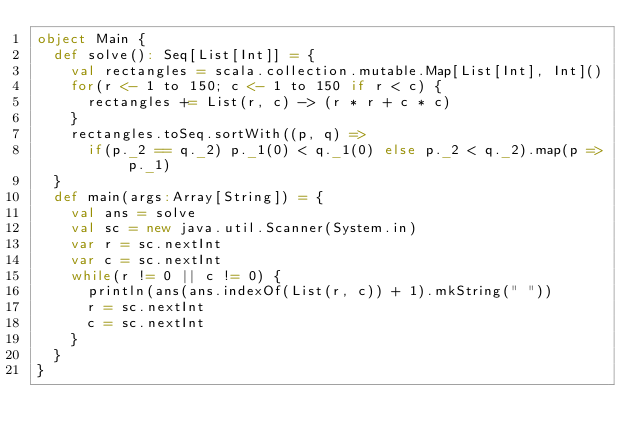<code> <loc_0><loc_0><loc_500><loc_500><_Scala_>object Main {
  def solve(): Seq[List[Int]] = {
    val rectangles = scala.collection.mutable.Map[List[Int], Int]()
    for(r <- 1 to 150; c <- 1 to 150 if r < c) {
      rectangles += List(r, c) -> (r * r + c * c)
    }
    rectangles.toSeq.sortWith((p, q) =>
      if(p._2 == q._2) p._1(0) < q._1(0) else p._2 < q._2).map(p => p._1)
  }
  def main(args:Array[String]) = {
    val ans = solve
    val sc = new java.util.Scanner(System.in)
    var r = sc.nextInt
    var c = sc.nextInt
    while(r != 0 || c != 0) {
      println(ans(ans.indexOf(List(r, c)) + 1).mkString(" "))
      r = sc.nextInt
      c = sc.nextInt
    }
  }
}</code> 